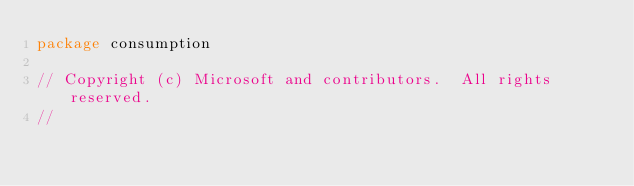<code> <loc_0><loc_0><loc_500><loc_500><_Go_>package consumption

// Copyright (c) Microsoft and contributors.  All rights reserved.
//</code> 